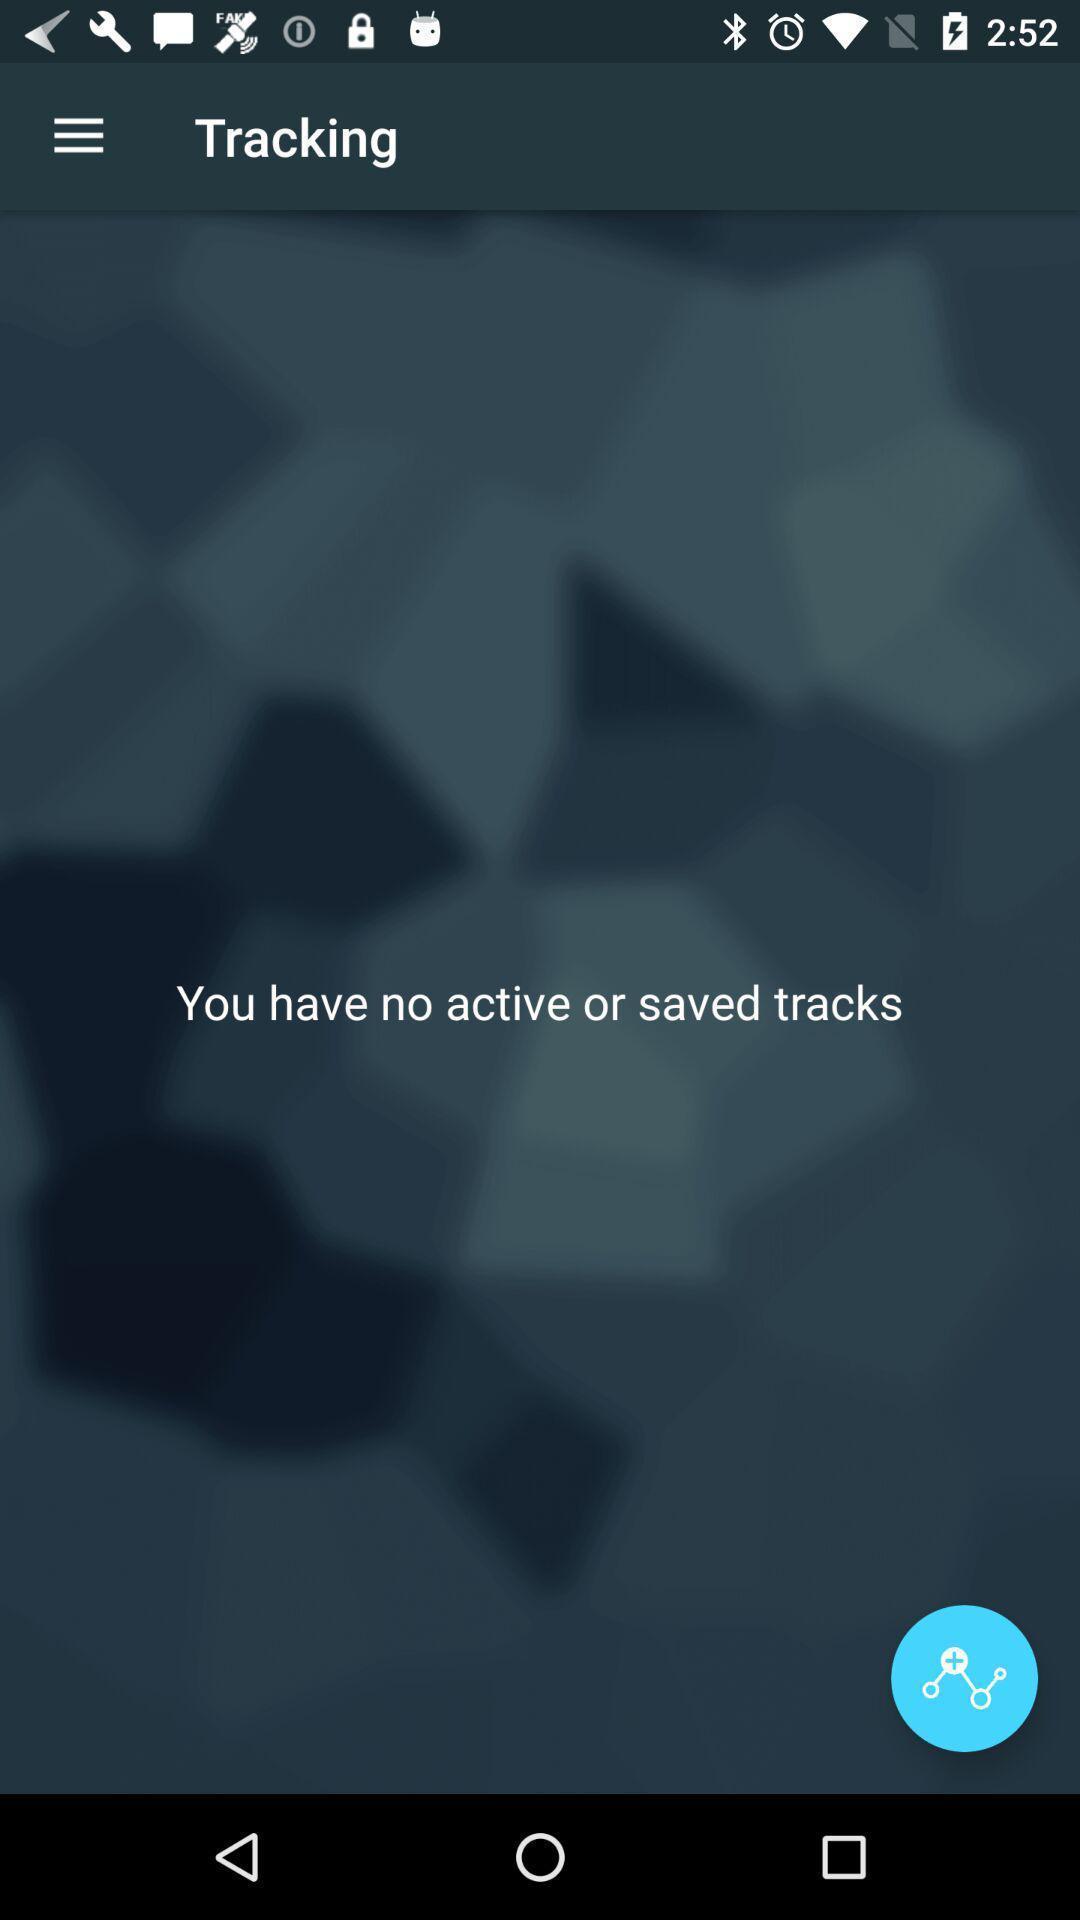Tell me what you see in this picture. Screen displaying the tracking page. 